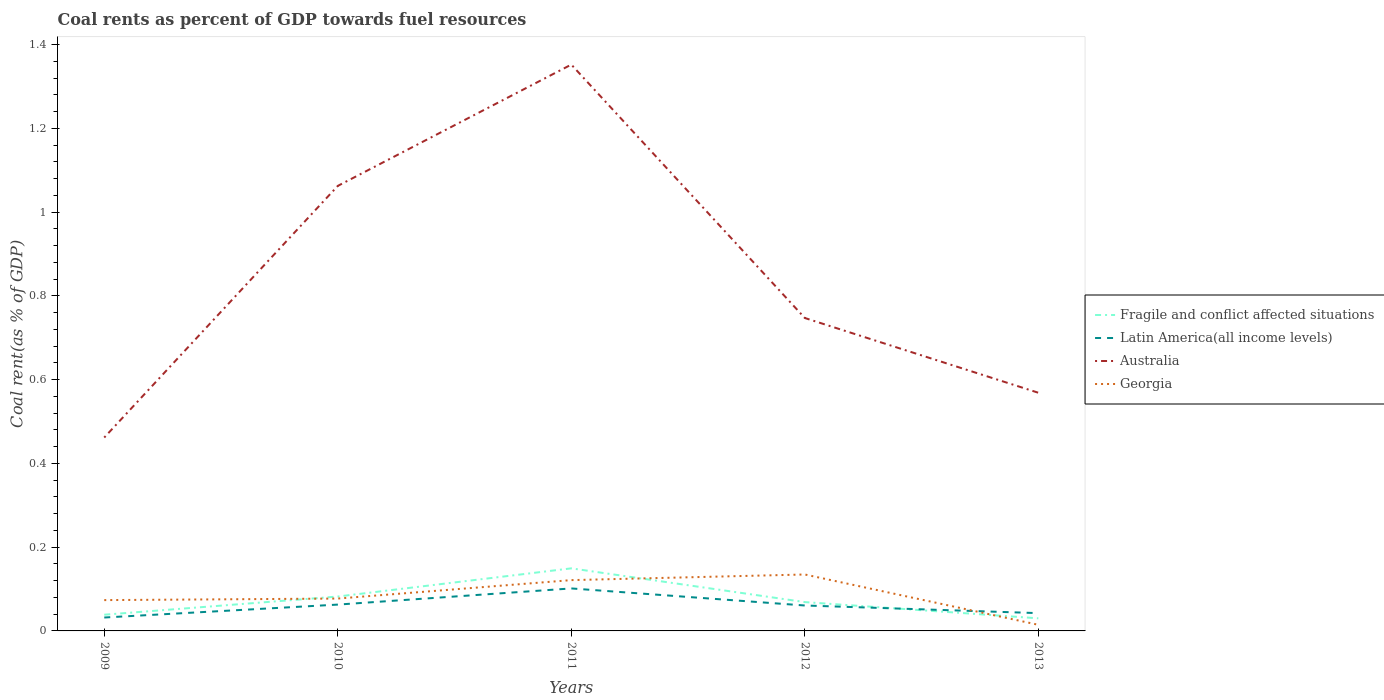Does the line corresponding to Latin America(all income levels) intersect with the line corresponding to Fragile and conflict affected situations?
Provide a succinct answer. Yes. Is the number of lines equal to the number of legend labels?
Give a very brief answer. Yes. Across all years, what is the maximum coal rent in Fragile and conflict affected situations?
Offer a terse response. 0.03. In which year was the coal rent in Latin America(all income levels) maximum?
Your answer should be compact. 2009. What is the total coal rent in Georgia in the graph?
Your answer should be compact. -0. What is the difference between the highest and the second highest coal rent in Australia?
Your answer should be very brief. 0.89. What is the difference between the highest and the lowest coal rent in Fragile and conflict affected situations?
Offer a very short reply. 2. How many lines are there?
Your answer should be very brief. 4. Are the values on the major ticks of Y-axis written in scientific E-notation?
Make the answer very short. No. Does the graph contain any zero values?
Your answer should be very brief. No. Where does the legend appear in the graph?
Provide a short and direct response. Center right. How are the legend labels stacked?
Provide a succinct answer. Vertical. What is the title of the graph?
Provide a succinct answer. Coal rents as percent of GDP towards fuel resources. What is the label or title of the Y-axis?
Offer a very short reply. Coal rent(as % of GDP). What is the Coal rent(as % of GDP) in Fragile and conflict affected situations in 2009?
Keep it short and to the point. 0.04. What is the Coal rent(as % of GDP) of Latin America(all income levels) in 2009?
Your response must be concise. 0.03. What is the Coal rent(as % of GDP) of Australia in 2009?
Your response must be concise. 0.46. What is the Coal rent(as % of GDP) in Georgia in 2009?
Provide a short and direct response. 0.07. What is the Coal rent(as % of GDP) of Fragile and conflict affected situations in 2010?
Make the answer very short. 0.08. What is the Coal rent(as % of GDP) in Latin America(all income levels) in 2010?
Your answer should be compact. 0.06. What is the Coal rent(as % of GDP) in Australia in 2010?
Make the answer very short. 1.06. What is the Coal rent(as % of GDP) in Georgia in 2010?
Provide a succinct answer. 0.08. What is the Coal rent(as % of GDP) of Fragile and conflict affected situations in 2011?
Your response must be concise. 0.15. What is the Coal rent(as % of GDP) in Latin America(all income levels) in 2011?
Your answer should be compact. 0.1. What is the Coal rent(as % of GDP) of Australia in 2011?
Give a very brief answer. 1.35. What is the Coal rent(as % of GDP) in Georgia in 2011?
Your response must be concise. 0.12. What is the Coal rent(as % of GDP) in Fragile and conflict affected situations in 2012?
Ensure brevity in your answer.  0.07. What is the Coal rent(as % of GDP) of Latin America(all income levels) in 2012?
Offer a terse response. 0.06. What is the Coal rent(as % of GDP) of Australia in 2012?
Your answer should be compact. 0.75. What is the Coal rent(as % of GDP) of Georgia in 2012?
Provide a succinct answer. 0.13. What is the Coal rent(as % of GDP) of Fragile and conflict affected situations in 2013?
Provide a short and direct response. 0.03. What is the Coal rent(as % of GDP) in Latin America(all income levels) in 2013?
Ensure brevity in your answer.  0.04. What is the Coal rent(as % of GDP) in Australia in 2013?
Ensure brevity in your answer.  0.57. What is the Coal rent(as % of GDP) of Georgia in 2013?
Offer a very short reply. 0.01. Across all years, what is the maximum Coal rent(as % of GDP) in Fragile and conflict affected situations?
Your answer should be very brief. 0.15. Across all years, what is the maximum Coal rent(as % of GDP) in Latin America(all income levels)?
Ensure brevity in your answer.  0.1. Across all years, what is the maximum Coal rent(as % of GDP) of Australia?
Give a very brief answer. 1.35. Across all years, what is the maximum Coal rent(as % of GDP) in Georgia?
Offer a very short reply. 0.13. Across all years, what is the minimum Coal rent(as % of GDP) in Fragile and conflict affected situations?
Provide a short and direct response. 0.03. Across all years, what is the minimum Coal rent(as % of GDP) of Latin America(all income levels)?
Make the answer very short. 0.03. Across all years, what is the minimum Coal rent(as % of GDP) in Australia?
Give a very brief answer. 0.46. Across all years, what is the minimum Coal rent(as % of GDP) of Georgia?
Your answer should be compact. 0.01. What is the total Coal rent(as % of GDP) in Fragile and conflict affected situations in the graph?
Your response must be concise. 0.37. What is the total Coal rent(as % of GDP) in Latin America(all income levels) in the graph?
Your response must be concise. 0.3. What is the total Coal rent(as % of GDP) in Australia in the graph?
Your response must be concise. 4.19. What is the total Coal rent(as % of GDP) of Georgia in the graph?
Make the answer very short. 0.42. What is the difference between the Coal rent(as % of GDP) of Fragile and conflict affected situations in 2009 and that in 2010?
Your answer should be compact. -0.04. What is the difference between the Coal rent(as % of GDP) in Latin America(all income levels) in 2009 and that in 2010?
Provide a short and direct response. -0.03. What is the difference between the Coal rent(as % of GDP) in Australia in 2009 and that in 2010?
Your answer should be compact. -0.6. What is the difference between the Coal rent(as % of GDP) in Georgia in 2009 and that in 2010?
Make the answer very short. -0. What is the difference between the Coal rent(as % of GDP) of Fragile and conflict affected situations in 2009 and that in 2011?
Make the answer very short. -0.11. What is the difference between the Coal rent(as % of GDP) of Latin America(all income levels) in 2009 and that in 2011?
Offer a very short reply. -0.07. What is the difference between the Coal rent(as % of GDP) of Australia in 2009 and that in 2011?
Keep it short and to the point. -0.89. What is the difference between the Coal rent(as % of GDP) of Georgia in 2009 and that in 2011?
Provide a short and direct response. -0.05. What is the difference between the Coal rent(as % of GDP) of Fragile and conflict affected situations in 2009 and that in 2012?
Offer a very short reply. -0.03. What is the difference between the Coal rent(as % of GDP) in Latin America(all income levels) in 2009 and that in 2012?
Your answer should be very brief. -0.03. What is the difference between the Coal rent(as % of GDP) in Australia in 2009 and that in 2012?
Your answer should be very brief. -0.29. What is the difference between the Coal rent(as % of GDP) in Georgia in 2009 and that in 2012?
Keep it short and to the point. -0.06. What is the difference between the Coal rent(as % of GDP) in Fragile and conflict affected situations in 2009 and that in 2013?
Provide a succinct answer. 0.01. What is the difference between the Coal rent(as % of GDP) in Latin America(all income levels) in 2009 and that in 2013?
Offer a terse response. -0.01. What is the difference between the Coal rent(as % of GDP) of Australia in 2009 and that in 2013?
Your answer should be very brief. -0.11. What is the difference between the Coal rent(as % of GDP) in Georgia in 2009 and that in 2013?
Offer a terse response. 0.06. What is the difference between the Coal rent(as % of GDP) in Fragile and conflict affected situations in 2010 and that in 2011?
Ensure brevity in your answer.  -0.07. What is the difference between the Coal rent(as % of GDP) in Latin America(all income levels) in 2010 and that in 2011?
Offer a terse response. -0.04. What is the difference between the Coal rent(as % of GDP) of Australia in 2010 and that in 2011?
Your answer should be very brief. -0.29. What is the difference between the Coal rent(as % of GDP) in Georgia in 2010 and that in 2011?
Offer a very short reply. -0.04. What is the difference between the Coal rent(as % of GDP) of Fragile and conflict affected situations in 2010 and that in 2012?
Provide a short and direct response. 0.01. What is the difference between the Coal rent(as % of GDP) of Latin America(all income levels) in 2010 and that in 2012?
Ensure brevity in your answer.  0. What is the difference between the Coal rent(as % of GDP) of Australia in 2010 and that in 2012?
Make the answer very short. 0.32. What is the difference between the Coal rent(as % of GDP) of Georgia in 2010 and that in 2012?
Keep it short and to the point. -0.06. What is the difference between the Coal rent(as % of GDP) of Fragile and conflict affected situations in 2010 and that in 2013?
Offer a terse response. 0.05. What is the difference between the Coal rent(as % of GDP) in Latin America(all income levels) in 2010 and that in 2013?
Offer a very short reply. 0.02. What is the difference between the Coal rent(as % of GDP) in Australia in 2010 and that in 2013?
Your response must be concise. 0.49. What is the difference between the Coal rent(as % of GDP) in Georgia in 2010 and that in 2013?
Make the answer very short. 0.06. What is the difference between the Coal rent(as % of GDP) in Fragile and conflict affected situations in 2011 and that in 2012?
Give a very brief answer. 0.08. What is the difference between the Coal rent(as % of GDP) in Latin America(all income levels) in 2011 and that in 2012?
Your answer should be compact. 0.04. What is the difference between the Coal rent(as % of GDP) in Australia in 2011 and that in 2012?
Keep it short and to the point. 0.61. What is the difference between the Coal rent(as % of GDP) in Georgia in 2011 and that in 2012?
Your answer should be very brief. -0.01. What is the difference between the Coal rent(as % of GDP) of Fragile and conflict affected situations in 2011 and that in 2013?
Provide a short and direct response. 0.12. What is the difference between the Coal rent(as % of GDP) in Latin America(all income levels) in 2011 and that in 2013?
Offer a very short reply. 0.06. What is the difference between the Coal rent(as % of GDP) in Australia in 2011 and that in 2013?
Provide a succinct answer. 0.78. What is the difference between the Coal rent(as % of GDP) in Georgia in 2011 and that in 2013?
Ensure brevity in your answer.  0.11. What is the difference between the Coal rent(as % of GDP) of Fragile and conflict affected situations in 2012 and that in 2013?
Your response must be concise. 0.04. What is the difference between the Coal rent(as % of GDP) of Latin America(all income levels) in 2012 and that in 2013?
Provide a short and direct response. 0.02. What is the difference between the Coal rent(as % of GDP) of Australia in 2012 and that in 2013?
Offer a very short reply. 0.18. What is the difference between the Coal rent(as % of GDP) in Georgia in 2012 and that in 2013?
Your answer should be very brief. 0.12. What is the difference between the Coal rent(as % of GDP) of Fragile and conflict affected situations in 2009 and the Coal rent(as % of GDP) of Latin America(all income levels) in 2010?
Your response must be concise. -0.02. What is the difference between the Coal rent(as % of GDP) of Fragile and conflict affected situations in 2009 and the Coal rent(as % of GDP) of Australia in 2010?
Offer a terse response. -1.02. What is the difference between the Coal rent(as % of GDP) in Fragile and conflict affected situations in 2009 and the Coal rent(as % of GDP) in Georgia in 2010?
Your answer should be very brief. -0.04. What is the difference between the Coal rent(as % of GDP) of Latin America(all income levels) in 2009 and the Coal rent(as % of GDP) of Australia in 2010?
Give a very brief answer. -1.03. What is the difference between the Coal rent(as % of GDP) of Latin America(all income levels) in 2009 and the Coal rent(as % of GDP) of Georgia in 2010?
Give a very brief answer. -0.05. What is the difference between the Coal rent(as % of GDP) in Australia in 2009 and the Coal rent(as % of GDP) in Georgia in 2010?
Your response must be concise. 0.38. What is the difference between the Coal rent(as % of GDP) of Fragile and conflict affected situations in 2009 and the Coal rent(as % of GDP) of Latin America(all income levels) in 2011?
Your response must be concise. -0.06. What is the difference between the Coal rent(as % of GDP) in Fragile and conflict affected situations in 2009 and the Coal rent(as % of GDP) in Australia in 2011?
Provide a succinct answer. -1.31. What is the difference between the Coal rent(as % of GDP) of Fragile and conflict affected situations in 2009 and the Coal rent(as % of GDP) of Georgia in 2011?
Make the answer very short. -0.08. What is the difference between the Coal rent(as % of GDP) of Latin America(all income levels) in 2009 and the Coal rent(as % of GDP) of Australia in 2011?
Make the answer very short. -1.32. What is the difference between the Coal rent(as % of GDP) of Latin America(all income levels) in 2009 and the Coal rent(as % of GDP) of Georgia in 2011?
Offer a terse response. -0.09. What is the difference between the Coal rent(as % of GDP) of Australia in 2009 and the Coal rent(as % of GDP) of Georgia in 2011?
Ensure brevity in your answer.  0.34. What is the difference between the Coal rent(as % of GDP) of Fragile and conflict affected situations in 2009 and the Coal rent(as % of GDP) of Latin America(all income levels) in 2012?
Give a very brief answer. -0.02. What is the difference between the Coal rent(as % of GDP) of Fragile and conflict affected situations in 2009 and the Coal rent(as % of GDP) of Australia in 2012?
Offer a terse response. -0.71. What is the difference between the Coal rent(as % of GDP) in Fragile and conflict affected situations in 2009 and the Coal rent(as % of GDP) in Georgia in 2012?
Offer a terse response. -0.1. What is the difference between the Coal rent(as % of GDP) in Latin America(all income levels) in 2009 and the Coal rent(as % of GDP) in Australia in 2012?
Give a very brief answer. -0.72. What is the difference between the Coal rent(as % of GDP) in Latin America(all income levels) in 2009 and the Coal rent(as % of GDP) in Georgia in 2012?
Ensure brevity in your answer.  -0.1. What is the difference between the Coal rent(as % of GDP) of Australia in 2009 and the Coal rent(as % of GDP) of Georgia in 2012?
Keep it short and to the point. 0.33. What is the difference between the Coal rent(as % of GDP) in Fragile and conflict affected situations in 2009 and the Coal rent(as % of GDP) in Latin America(all income levels) in 2013?
Make the answer very short. -0. What is the difference between the Coal rent(as % of GDP) of Fragile and conflict affected situations in 2009 and the Coal rent(as % of GDP) of Australia in 2013?
Offer a terse response. -0.53. What is the difference between the Coal rent(as % of GDP) of Fragile and conflict affected situations in 2009 and the Coal rent(as % of GDP) of Georgia in 2013?
Make the answer very short. 0.02. What is the difference between the Coal rent(as % of GDP) of Latin America(all income levels) in 2009 and the Coal rent(as % of GDP) of Australia in 2013?
Ensure brevity in your answer.  -0.54. What is the difference between the Coal rent(as % of GDP) in Latin America(all income levels) in 2009 and the Coal rent(as % of GDP) in Georgia in 2013?
Your answer should be compact. 0.02. What is the difference between the Coal rent(as % of GDP) in Australia in 2009 and the Coal rent(as % of GDP) in Georgia in 2013?
Offer a very short reply. 0.45. What is the difference between the Coal rent(as % of GDP) of Fragile and conflict affected situations in 2010 and the Coal rent(as % of GDP) of Latin America(all income levels) in 2011?
Ensure brevity in your answer.  -0.02. What is the difference between the Coal rent(as % of GDP) of Fragile and conflict affected situations in 2010 and the Coal rent(as % of GDP) of Australia in 2011?
Offer a very short reply. -1.27. What is the difference between the Coal rent(as % of GDP) in Fragile and conflict affected situations in 2010 and the Coal rent(as % of GDP) in Georgia in 2011?
Make the answer very short. -0.04. What is the difference between the Coal rent(as % of GDP) of Latin America(all income levels) in 2010 and the Coal rent(as % of GDP) of Australia in 2011?
Your answer should be compact. -1.29. What is the difference between the Coal rent(as % of GDP) of Latin America(all income levels) in 2010 and the Coal rent(as % of GDP) of Georgia in 2011?
Your response must be concise. -0.06. What is the difference between the Coal rent(as % of GDP) in Australia in 2010 and the Coal rent(as % of GDP) in Georgia in 2011?
Make the answer very short. 0.94. What is the difference between the Coal rent(as % of GDP) of Fragile and conflict affected situations in 2010 and the Coal rent(as % of GDP) of Latin America(all income levels) in 2012?
Provide a succinct answer. 0.02. What is the difference between the Coal rent(as % of GDP) in Fragile and conflict affected situations in 2010 and the Coal rent(as % of GDP) in Australia in 2012?
Your response must be concise. -0.67. What is the difference between the Coal rent(as % of GDP) in Fragile and conflict affected situations in 2010 and the Coal rent(as % of GDP) in Georgia in 2012?
Keep it short and to the point. -0.05. What is the difference between the Coal rent(as % of GDP) of Latin America(all income levels) in 2010 and the Coal rent(as % of GDP) of Australia in 2012?
Offer a very short reply. -0.68. What is the difference between the Coal rent(as % of GDP) in Latin America(all income levels) in 2010 and the Coal rent(as % of GDP) in Georgia in 2012?
Offer a terse response. -0.07. What is the difference between the Coal rent(as % of GDP) in Australia in 2010 and the Coal rent(as % of GDP) in Georgia in 2012?
Your response must be concise. 0.93. What is the difference between the Coal rent(as % of GDP) of Fragile and conflict affected situations in 2010 and the Coal rent(as % of GDP) of Latin America(all income levels) in 2013?
Offer a very short reply. 0.04. What is the difference between the Coal rent(as % of GDP) of Fragile and conflict affected situations in 2010 and the Coal rent(as % of GDP) of Australia in 2013?
Your response must be concise. -0.49. What is the difference between the Coal rent(as % of GDP) of Fragile and conflict affected situations in 2010 and the Coal rent(as % of GDP) of Georgia in 2013?
Give a very brief answer. 0.07. What is the difference between the Coal rent(as % of GDP) in Latin America(all income levels) in 2010 and the Coal rent(as % of GDP) in Australia in 2013?
Your answer should be compact. -0.51. What is the difference between the Coal rent(as % of GDP) of Latin America(all income levels) in 2010 and the Coal rent(as % of GDP) of Georgia in 2013?
Offer a very short reply. 0.05. What is the difference between the Coal rent(as % of GDP) of Australia in 2010 and the Coal rent(as % of GDP) of Georgia in 2013?
Offer a terse response. 1.05. What is the difference between the Coal rent(as % of GDP) of Fragile and conflict affected situations in 2011 and the Coal rent(as % of GDP) of Latin America(all income levels) in 2012?
Ensure brevity in your answer.  0.09. What is the difference between the Coal rent(as % of GDP) in Fragile and conflict affected situations in 2011 and the Coal rent(as % of GDP) in Australia in 2012?
Make the answer very short. -0.6. What is the difference between the Coal rent(as % of GDP) of Fragile and conflict affected situations in 2011 and the Coal rent(as % of GDP) of Georgia in 2012?
Provide a short and direct response. 0.01. What is the difference between the Coal rent(as % of GDP) of Latin America(all income levels) in 2011 and the Coal rent(as % of GDP) of Australia in 2012?
Offer a terse response. -0.65. What is the difference between the Coal rent(as % of GDP) in Latin America(all income levels) in 2011 and the Coal rent(as % of GDP) in Georgia in 2012?
Provide a short and direct response. -0.03. What is the difference between the Coal rent(as % of GDP) in Australia in 2011 and the Coal rent(as % of GDP) in Georgia in 2012?
Provide a succinct answer. 1.22. What is the difference between the Coal rent(as % of GDP) of Fragile and conflict affected situations in 2011 and the Coal rent(as % of GDP) of Latin America(all income levels) in 2013?
Your response must be concise. 0.11. What is the difference between the Coal rent(as % of GDP) in Fragile and conflict affected situations in 2011 and the Coal rent(as % of GDP) in Australia in 2013?
Offer a very short reply. -0.42. What is the difference between the Coal rent(as % of GDP) of Fragile and conflict affected situations in 2011 and the Coal rent(as % of GDP) of Georgia in 2013?
Your answer should be compact. 0.13. What is the difference between the Coal rent(as % of GDP) of Latin America(all income levels) in 2011 and the Coal rent(as % of GDP) of Australia in 2013?
Your response must be concise. -0.47. What is the difference between the Coal rent(as % of GDP) in Latin America(all income levels) in 2011 and the Coal rent(as % of GDP) in Georgia in 2013?
Provide a short and direct response. 0.09. What is the difference between the Coal rent(as % of GDP) of Australia in 2011 and the Coal rent(as % of GDP) of Georgia in 2013?
Keep it short and to the point. 1.34. What is the difference between the Coal rent(as % of GDP) in Fragile and conflict affected situations in 2012 and the Coal rent(as % of GDP) in Latin America(all income levels) in 2013?
Ensure brevity in your answer.  0.03. What is the difference between the Coal rent(as % of GDP) in Fragile and conflict affected situations in 2012 and the Coal rent(as % of GDP) in Australia in 2013?
Offer a terse response. -0.5. What is the difference between the Coal rent(as % of GDP) of Fragile and conflict affected situations in 2012 and the Coal rent(as % of GDP) of Georgia in 2013?
Provide a short and direct response. 0.05. What is the difference between the Coal rent(as % of GDP) in Latin America(all income levels) in 2012 and the Coal rent(as % of GDP) in Australia in 2013?
Your answer should be very brief. -0.51. What is the difference between the Coal rent(as % of GDP) in Latin America(all income levels) in 2012 and the Coal rent(as % of GDP) in Georgia in 2013?
Offer a terse response. 0.05. What is the difference between the Coal rent(as % of GDP) of Australia in 2012 and the Coal rent(as % of GDP) of Georgia in 2013?
Offer a very short reply. 0.73. What is the average Coal rent(as % of GDP) of Fragile and conflict affected situations per year?
Your response must be concise. 0.07. What is the average Coal rent(as % of GDP) in Latin America(all income levels) per year?
Keep it short and to the point. 0.06. What is the average Coal rent(as % of GDP) of Australia per year?
Keep it short and to the point. 0.84. What is the average Coal rent(as % of GDP) of Georgia per year?
Offer a terse response. 0.08. In the year 2009, what is the difference between the Coal rent(as % of GDP) in Fragile and conflict affected situations and Coal rent(as % of GDP) in Latin America(all income levels)?
Your response must be concise. 0.01. In the year 2009, what is the difference between the Coal rent(as % of GDP) in Fragile and conflict affected situations and Coal rent(as % of GDP) in Australia?
Keep it short and to the point. -0.42. In the year 2009, what is the difference between the Coal rent(as % of GDP) of Fragile and conflict affected situations and Coal rent(as % of GDP) of Georgia?
Your answer should be very brief. -0.03. In the year 2009, what is the difference between the Coal rent(as % of GDP) in Latin America(all income levels) and Coal rent(as % of GDP) in Australia?
Your answer should be compact. -0.43. In the year 2009, what is the difference between the Coal rent(as % of GDP) in Latin America(all income levels) and Coal rent(as % of GDP) in Georgia?
Make the answer very short. -0.04. In the year 2009, what is the difference between the Coal rent(as % of GDP) of Australia and Coal rent(as % of GDP) of Georgia?
Offer a terse response. 0.39. In the year 2010, what is the difference between the Coal rent(as % of GDP) of Fragile and conflict affected situations and Coal rent(as % of GDP) of Latin America(all income levels)?
Your response must be concise. 0.02. In the year 2010, what is the difference between the Coal rent(as % of GDP) of Fragile and conflict affected situations and Coal rent(as % of GDP) of Australia?
Make the answer very short. -0.98. In the year 2010, what is the difference between the Coal rent(as % of GDP) of Fragile and conflict affected situations and Coal rent(as % of GDP) of Georgia?
Give a very brief answer. 0. In the year 2010, what is the difference between the Coal rent(as % of GDP) in Latin America(all income levels) and Coal rent(as % of GDP) in Australia?
Provide a short and direct response. -1. In the year 2010, what is the difference between the Coal rent(as % of GDP) of Latin America(all income levels) and Coal rent(as % of GDP) of Georgia?
Offer a very short reply. -0.01. In the year 2010, what is the difference between the Coal rent(as % of GDP) in Australia and Coal rent(as % of GDP) in Georgia?
Offer a very short reply. 0.99. In the year 2011, what is the difference between the Coal rent(as % of GDP) in Fragile and conflict affected situations and Coal rent(as % of GDP) in Latin America(all income levels)?
Offer a terse response. 0.05. In the year 2011, what is the difference between the Coal rent(as % of GDP) in Fragile and conflict affected situations and Coal rent(as % of GDP) in Australia?
Keep it short and to the point. -1.2. In the year 2011, what is the difference between the Coal rent(as % of GDP) of Fragile and conflict affected situations and Coal rent(as % of GDP) of Georgia?
Offer a very short reply. 0.03. In the year 2011, what is the difference between the Coal rent(as % of GDP) of Latin America(all income levels) and Coal rent(as % of GDP) of Australia?
Keep it short and to the point. -1.25. In the year 2011, what is the difference between the Coal rent(as % of GDP) in Latin America(all income levels) and Coal rent(as % of GDP) in Georgia?
Keep it short and to the point. -0.02. In the year 2011, what is the difference between the Coal rent(as % of GDP) in Australia and Coal rent(as % of GDP) in Georgia?
Keep it short and to the point. 1.23. In the year 2012, what is the difference between the Coal rent(as % of GDP) of Fragile and conflict affected situations and Coal rent(as % of GDP) of Latin America(all income levels)?
Provide a short and direct response. 0.01. In the year 2012, what is the difference between the Coal rent(as % of GDP) in Fragile and conflict affected situations and Coal rent(as % of GDP) in Australia?
Your answer should be very brief. -0.68. In the year 2012, what is the difference between the Coal rent(as % of GDP) in Fragile and conflict affected situations and Coal rent(as % of GDP) in Georgia?
Offer a very short reply. -0.07. In the year 2012, what is the difference between the Coal rent(as % of GDP) of Latin America(all income levels) and Coal rent(as % of GDP) of Australia?
Your answer should be very brief. -0.69. In the year 2012, what is the difference between the Coal rent(as % of GDP) in Latin America(all income levels) and Coal rent(as % of GDP) in Georgia?
Offer a terse response. -0.07. In the year 2012, what is the difference between the Coal rent(as % of GDP) of Australia and Coal rent(as % of GDP) of Georgia?
Give a very brief answer. 0.61. In the year 2013, what is the difference between the Coal rent(as % of GDP) of Fragile and conflict affected situations and Coal rent(as % of GDP) of Latin America(all income levels)?
Your response must be concise. -0.01. In the year 2013, what is the difference between the Coal rent(as % of GDP) of Fragile and conflict affected situations and Coal rent(as % of GDP) of Australia?
Give a very brief answer. -0.54. In the year 2013, what is the difference between the Coal rent(as % of GDP) in Fragile and conflict affected situations and Coal rent(as % of GDP) in Georgia?
Provide a succinct answer. 0.02. In the year 2013, what is the difference between the Coal rent(as % of GDP) of Latin America(all income levels) and Coal rent(as % of GDP) of Australia?
Your response must be concise. -0.53. In the year 2013, what is the difference between the Coal rent(as % of GDP) of Latin America(all income levels) and Coal rent(as % of GDP) of Georgia?
Your answer should be compact. 0.03. In the year 2013, what is the difference between the Coal rent(as % of GDP) in Australia and Coal rent(as % of GDP) in Georgia?
Keep it short and to the point. 0.55. What is the ratio of the Coal rent(as % of GDP) in Fragile and conflict affected situations in 2009 to that in 2010?
Your answer should be very brief. 0.47. What is the ratio of the Coal rent(as % of GDP) in Latin America(all income levels) in 2009 to that in 2010?
Your response must be concise. 0.51. What is the ratio of the Coal rent(as % of GDP) in Australia in 2009 to that in 2010?
Provide a succinct answer. 0.43. What is the ratio of the Coal rent(as % of GDP) in Georgia in 2009 to that in 2010?
Offer a very short reply. 0.95. What is the ratio of the Coal rent(as % of GDP) in Fragile and conflict affected situations in 2009 to that in 2011?
Provide a short and direct response. 0.26. What is the ratio of the Coal rent(as % of GDP) of Latin America(all income levels) in 2009 to that in 2011?
Your answer should be compact. 0.32. What is the ratio of the Coal rent(as % of GDP) of Australia in 2009 to that in 2011?
Ensure brevity in your answer.  0.34. What is the ratio of the Coal rent(as % of GDP) in Georgia in 2009 to that in 2011?
Offer a very short reply. 0.61. What is the ratio of the Coal rent(as % of GDP) of Fragile and conflict affected situations in 2009 to that in 2012?
Ensure brevity in your answer.  0.56. What is the ratio of the Coal rent(as % of GDP) in Latin America(all income levels) in 2009 to that in 2012?
Your answer should be compact. 0.53. What is the ratio of the Coal rent(as % of GDP) in Australia in 2009 to that in 2012?
Provide a short and direct response. 0.62. What is the ratio of the Coal rent(as % of GDP) of Georgia in 2009 to that in 2012?
Make the answer very short. 0.55. What is the ratio of the Coal rent(as % of GDP) in Fragile and conflict affected situations in 2009 to that in 2013?
Offer a very short reply. 1.29. What is the ratio of the Coal rent(as % of GDP) of Latin America(all income levels) in 2009 to that in 2013?
Your answer should be very brief. 0.75. What is the ratio of the Coal rent(as % of GDP) of Australia in 2009 to that in 2013?
Make the answer very short. 0.81. What is the ratio of the Coal rent(as % of GDP) of Georgia in 2009 to that in 2013?
Give a very brief answer. 5.03. What is the ratio of the Coal rent(as % of GDP) of Fragile and conflict affected situations in 2010 to that in 2011?
Ensure brevity in your answer.  0.55. What is the ratio of the Coal rent(as % of GDP) of Latin America(all income levels) in 2010 to that in 2011?
Make the answer very short. 0.62. What is the ratio of the Coal rent(as % of GDP) of Australia in 2010 to that in 2011?
Offer a very short reply. 0.79. What is the ratio of the Coal rent(as % of GDP) in Georgia in 2010 to that in 2011?
Your answer should be very brief. 0.64. What is the ratio of the Coal rent(as % of GDP) in Fragile and conflict affected situations in 2010 to that in 2012?
Ensure brevity in your answer.  1.19. What is the ratio of the Coal rent(as % of GDP) in Latin America(all income levels) in 2010 to that in 2012?
Ensure brevity in your answer.  1.04. What is the ratio of the Coal rent(as % of GDP) of Australia in 2010 to that in 2012?
Provide a short and direct response. 1.42. What is the ratio of the Coal rent(as % of GDP) of Georgia in 2010 to that in 2012?
Offer a terse response. 0.57. What is the ratio of the Coal rent(as % of GDP) in Fragile and conflict affected situations in 2010 to that in 2013?
Your answer should be very brief. 2.73. What is the ratio of the Coal rent(as % of GDP) in Latin America(all income levels) in 2010 to that in 2013?
Make the answer very short. 1.48. What is the ratio of the Coal rent(as % of GDP) in Australia in 2010 to that in 2013?
Provide a succinct answer. 1.87. What is the ratio of the Coal rent(as % of GDP) of Georgia in 2010 to that in 2013?
Ensure brevity in your answer.  5.28. What is the ratio of the Coal rent(as % of GDP) of Fragile and conflict affected situations in 2011 to that in 2012?
Your answer should be very brief. 2.17. What is the ratio of the Coal rent(as % of GDP) of Latin America(all income levels) in 2011 to that in 2012?
Make the answer very short. 1.67. What is the ratio of the Coal rent(as % of GDP) of Australia in 2011 to that in 2012?
Provide a succinct answer. 1.81. What is the ratio of the Coal rent(as % of GDP) in Georgia in 2011 to that in 2012?
Give a very brief answer. 0.9. What is the ratio of the Coal rent(as % of GDP) in Fragile and conflict affected situations in 2011 to that in 2013?
Offer a terse response. 4.97. What is the ratio of the Coal rent(as % of GDP) of Latin America(all income levels) in 2011 to that in 2013?
Provide a succinct answer. 2.39. What is the ratio of the Coal rent(as % of GDP) of Australia in 2011 to that in 2013?
Your answer should be compact. 2.38. What is the ratio of the Coal rent(as % of GDP) of Georgia in 2011 to that in 2013?
Provide a short and direct response. 8.29. What is the ratio of the Coal rent(as % of GDP) in Fragile and conflict affected situations in 2012 to that in 2013?
Your response must be concise. 2.29. What is the ratio of the Coal rent(as % of GDP) in Latin America(all income levels) in 2012 to that in 2013?
Make the answer very short. 1.43. What is the ratio of the Coal rent(as % of GDP) in Australia in 2012 to that in 2013?
Ensure brevity in your answer.  1.31. What is the ratio of the Coal rent(as % of GDP) in Georgia in 2012 to that in 2013?
Your answer should be compact. 9.21. What is the difference between the highest and the second highest Coal rent(as % of GDP) in Fragile and conflict affected situations?
Ensure brevity in your answer.  0.07. What is the difference between the highest and the second highest Coal rent(as % of GDP) in Latin America(all income levels)?
Provide a short and direct response. 0.04. What is the difference between the highest and the second highest Coal rent(as % of GDP) in Australia?
Offer a terse response. 0.29. What is the difference between the highest and the second highest Coal rent(as % of GDP) in Georgia?
Ensure brevity in your answer.  0.01. What is the difference between the highest and the lowest Coal rent(as % of GDP) of Fragile and conflict affected situations?
Your response must be concise. 0.12. What is the difference between the highest and the lowest Coal rent(as % of GDP) of Latin America(all income levels)?
Offer a very short reply. 0.07. What is the difference between the highest and the lowest Coal rent(as % of GDP) of Australia?
Provide a short and direct response. 0.89. What is the difference between the highest and the lowest Coal rent(as % of GDP) of Georgia?
Keep it short and to the point. 0.12. 